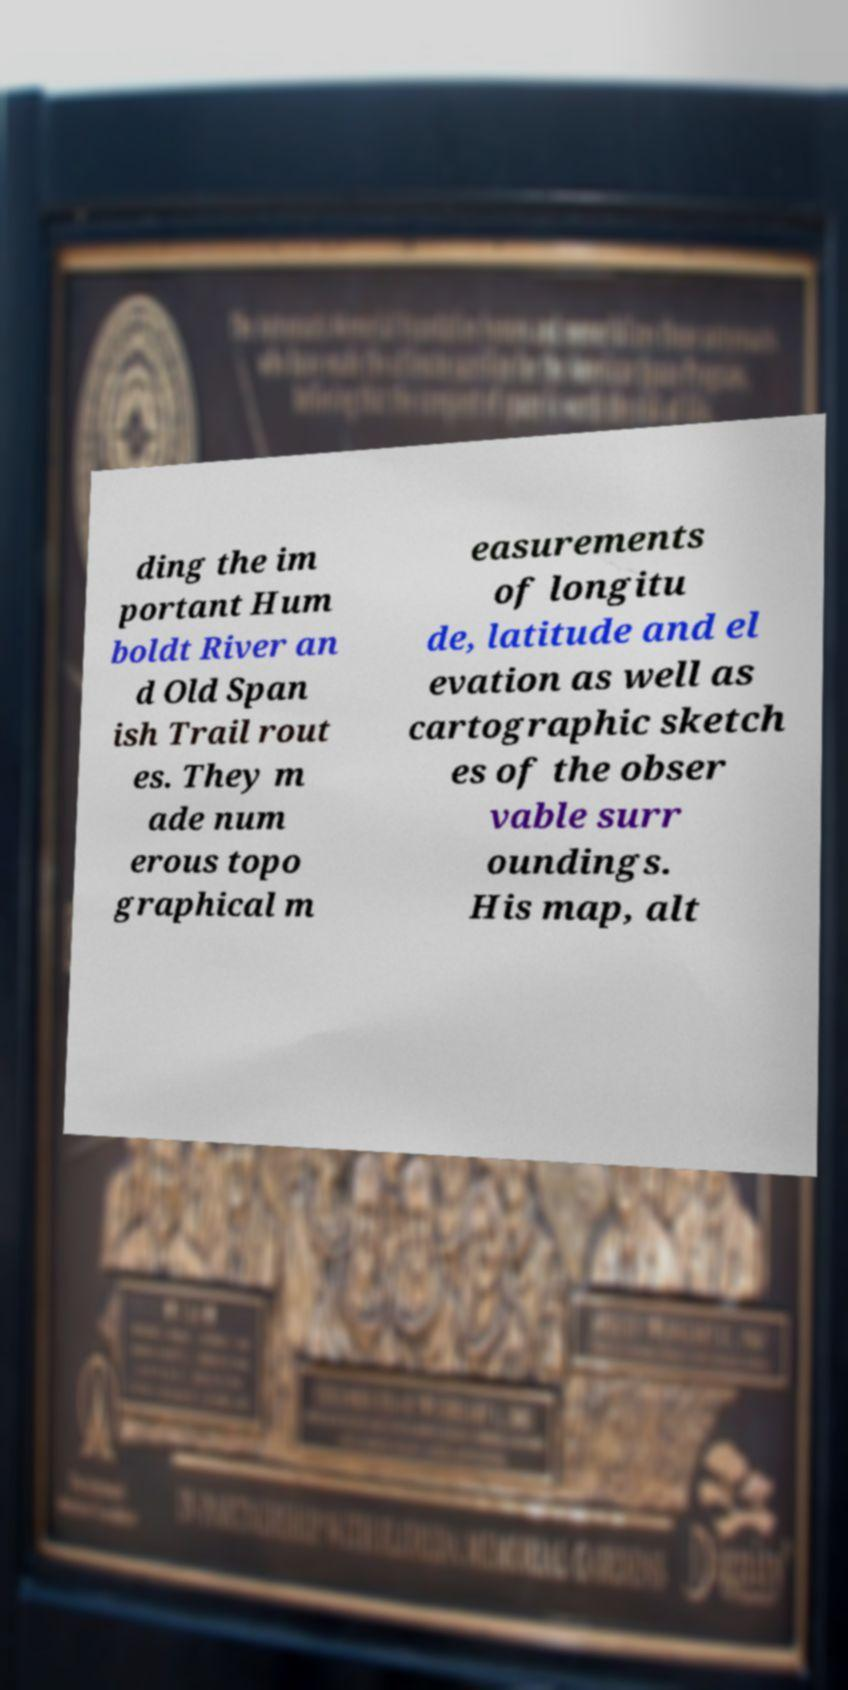Can you read and provide the text displayed in the image?This photo seems to have some interesting text. Can you extract and type it out for me? ding the im portant Hum boldt River an d Old Span ish Trail rout es. They m ade num erous topo graphical m easurements of longitu de, latitude and el evation as well as cartographic sketch es of the obser vable surr oundings. His map, alt 